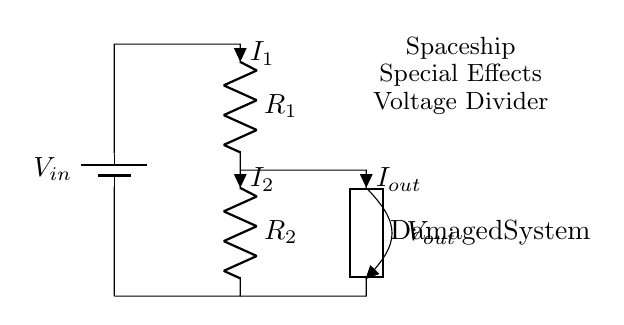What is the input voltage in the circuit? The input voltage is denoted as V_{in} at the top of the circuit, showing the source of voltage applied to the divider.
Answer: V_{in} What are the values of the resistors in the circuit? The circuit diagram labels the resistors as R_1 and R_2, but the specific numerical values are not given in the diagram.
Answer: R_1 and R_2 What does the current I_{out} represent in the circuit? The current I_{out} represents the current flowing through the generic component labeled "Damaged System," indicating the output of the voltage divider circuit to this load.
Answer: I_{out} How are the resistors connected in this circuit? The resistors R_1 and R_2 are connected in series, as they are arranged one after the other along the same path from input to ground.
Answer: In series What is the purpose of this circuit? The circuit is designed to serve as a voltage divider, which simulates the damaged electrical systems of a spaceship in a special effects rig, allowing for control over voltage to outputs.
Answer: Voltage divider What happens to the output voltage V_{out} if R_1 is increased? If R_1 is increased, the output voltage V_{out} will increase because the voltage across R_2 will decrease relative to the applied voltage, allowing more voltage to drop across R_1.
Answer: Increases How can you describe the overall function of the circuit? The overall function of the circuit is to divide the input voltage into a lower output voltage based on the resistance values of R_1 and R_2, simulating the impact of damages in a spaceship’s electrical system.
Answer: Voltage division 